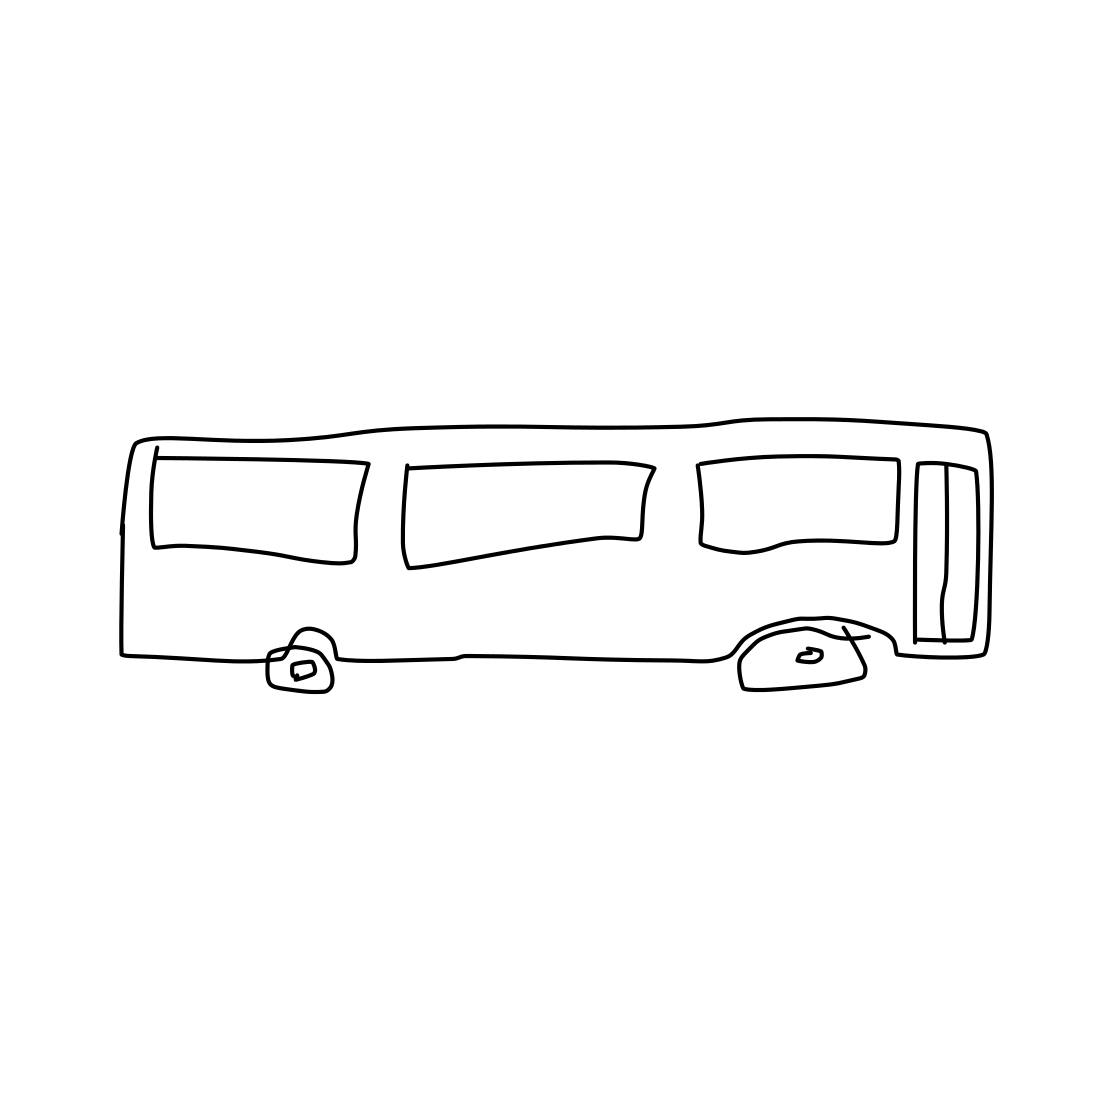What can you tell me about the style of this drawing? The drawing is minimalist and appears to be hand-drawn with simple outlines. It lacks detail and shading, giving it an abstract and schematic appearance, often used in symbolic representations or instructional materials. 